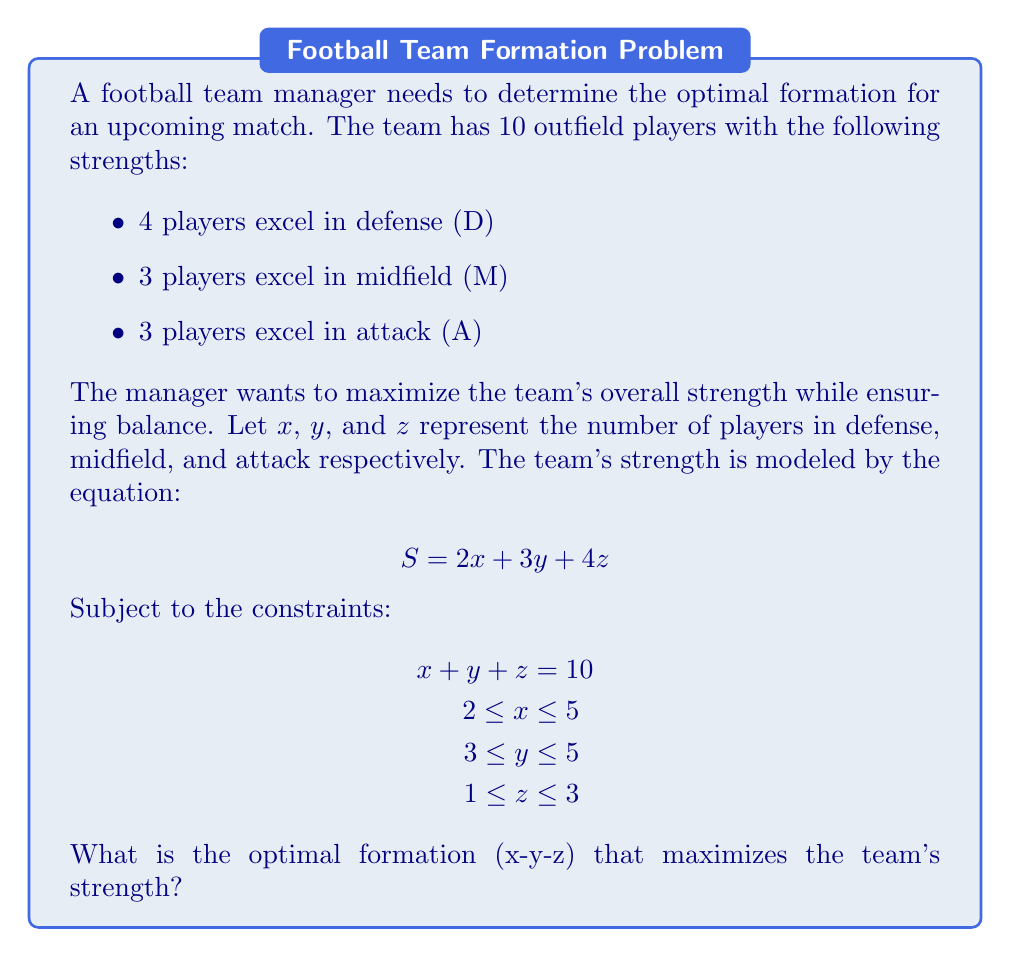Can you solve this math problem? To solve this problem, we'll use the following steps:

1) First, we need to maximize the strength equation:
   $$ S = 2x + 3y + 4z $$

2) Given the constraints:
   $$ x + y + z = 10 $$
   $$ 2 \leq x \leq 5 $$
   $$ 3 \leq y \leq 5 $$
   $$ 1 \leq z \leq 3 $$

3) To maximize S, we should prioritize higher coefficients. The coefficient of z (4) is the highest, so we should maximize z within its constraints. The maximum value for z is 3.

4) After setting z = 3, we have 7 players left to distribute between x and y:
   $$ x + y = 7 $$

5) Now, between x and y, y has a higher coefficient (3 vs 2), so we should maximize y. The maximum value for y is 5.

6) After setting y = 5, we can solve for x:
   $$ x + 5 = 7 $$
   $$ x = 2 $$

7) Let's verify if this solution satisfies all constraints:
   - x = 2 (satisfies 2 ≤ x ≤ 5)
   - y = 5 (satisfies 3 ≤ y ≤ 5)
   - z = 3 (satisfies 1 ≤ z ≤ 3)
   - x + y + z = 2 + 5 + 3 = 10 (satisfies the total player constraint)

8) Therefore, the optimal formation is 2-5-3.

9) The maximum strength achieved is:
   $$ S = 2(2) + 3(5) + 4(3) = 4 + 15 + 12 = 31 $$
Answer: 2-5-3 